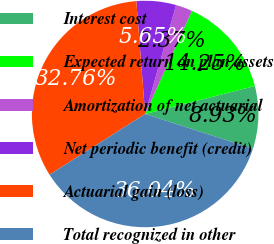Convert chart. <chart><loc_0><loc_0><loc_500><loc_500><pie_chart><fcel>Interest cost<fcel>Expected return on plan assets<fcel>Amortization of net actuarial<fcel>Net periodic benefit (credit)<fcel>Actuarial gain (loss)<fcel>Total recognized in other<nl><fcel>8.93%<fcel>14.25%<fcel>2.37%<fcel>5.65%<fcel>32.76%<fcel>36.04%<nl></chart> 